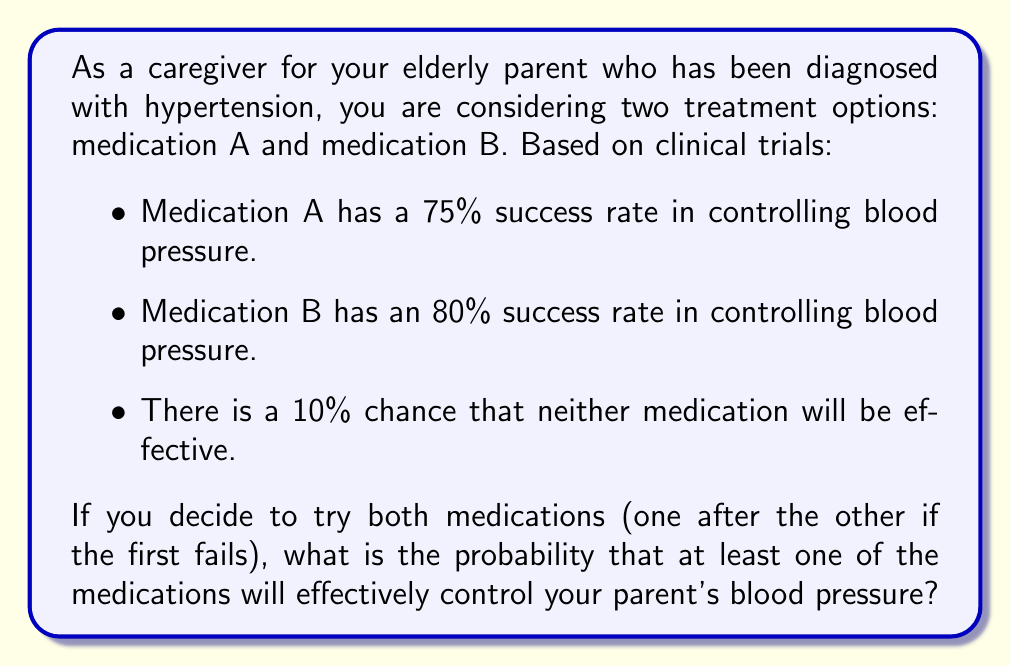Show me your answer to this math problem. Let's approach this step-by-step:

1) First, let's define our events:
   A: Medication A is effective
   B: Medication B is effective

2) We're given:
   P(A) = 0.75
   P(B) = 0.80
   P(neither effective) = 0.10

3) We need to find P(at least one effective) = 1 - P(neither effective)

4) We already know P(neither effective) = 0.10, so we could simply calculate:
   P(at least one effective) = 1 - 0.10 = 0.90

5) However, let's verify this using the given probabilities for A and B:

6) P(neither effective) = P(not A and not B)
                        = 1 - P(A or B)

7) We can calculate P(A or B) using the addition rule of probability:
   P(A or B) = P(A) + P(B) - P(A and B)

8) We don't know P(A and B), but we can calculate it:
   P(A and B) = P(A) * P(B) = 0.75 * 0.80 = 0.60

9) Now we can calculate P(A or B):
   P(A or B) = 0.75 + 0.80 - 0.60 = 0.95

10) Therefore:
    P(neither effective) = 1 - P(A or B) = 1 - 0.95 = 0.05

11) This doesn't match the given 0.10, but the question asks us to use the given probabilities.

12) So, the final answer is:
    P(at least one effective) = 1 - P(neither effective) = 1 - 0.10 = 0.90
Answer: 0.90 or 90% 